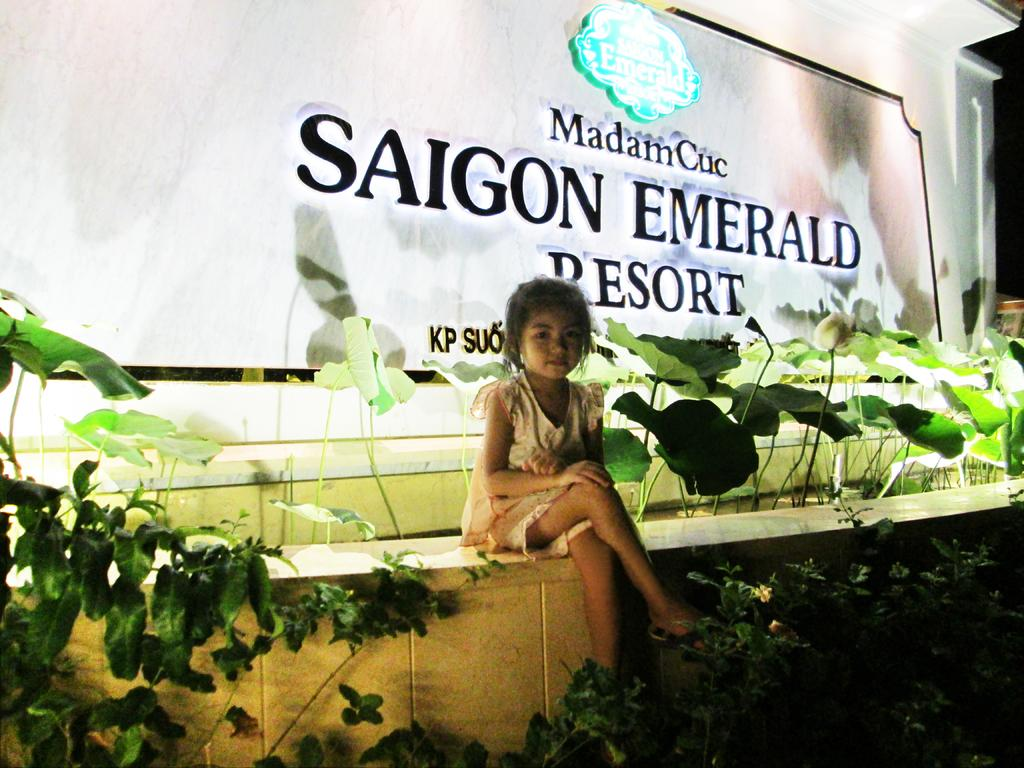What is the girl in the image doing? The girl is sitting on a wall in the image. What can be seen in the background of the image? There are plants in the image. What is the name board used for in the image? The name board is present in the image. Can you describe any other objects in the image? There are some objects in the image. What type of plane can be seen flying over the girl in the image? There is no plane visible in the image; it only features a girl sitting on a wall, plants, a name board, and some objects. 